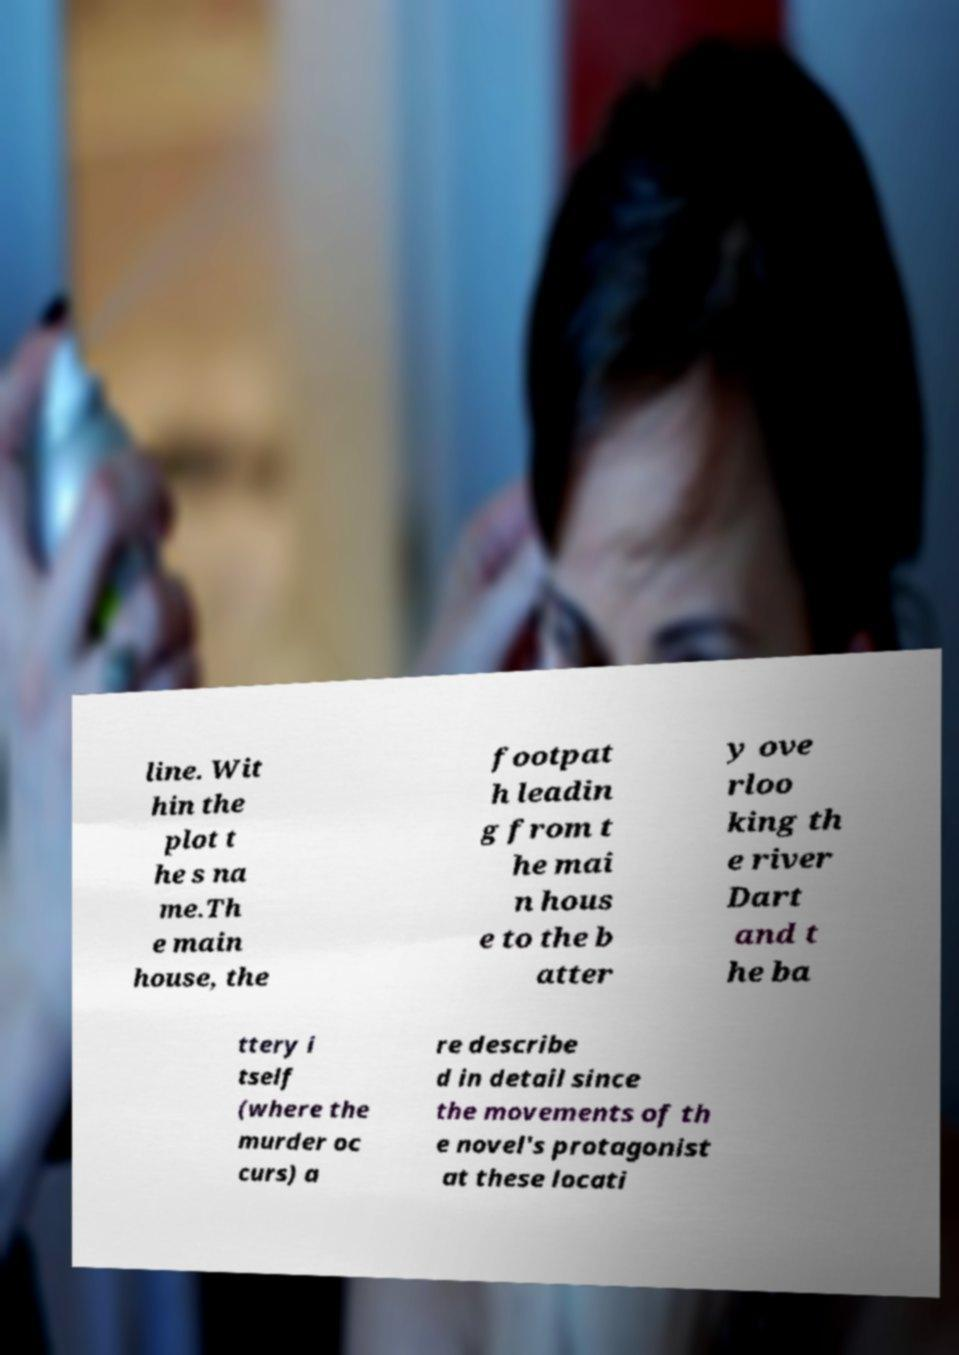There's text embedded in this image that I need extracted. Can you transcribe it verbatim? line. Wit hin the plot t he s na me.Th e main house, the footpat h leadin g from t he mai n hous e to the b atter y ove rloo king th e river Dart and t he ba ttery i tself (where the murder oc curs) a re describe d in detail since the movements of th e novel's protagonist at these locati 